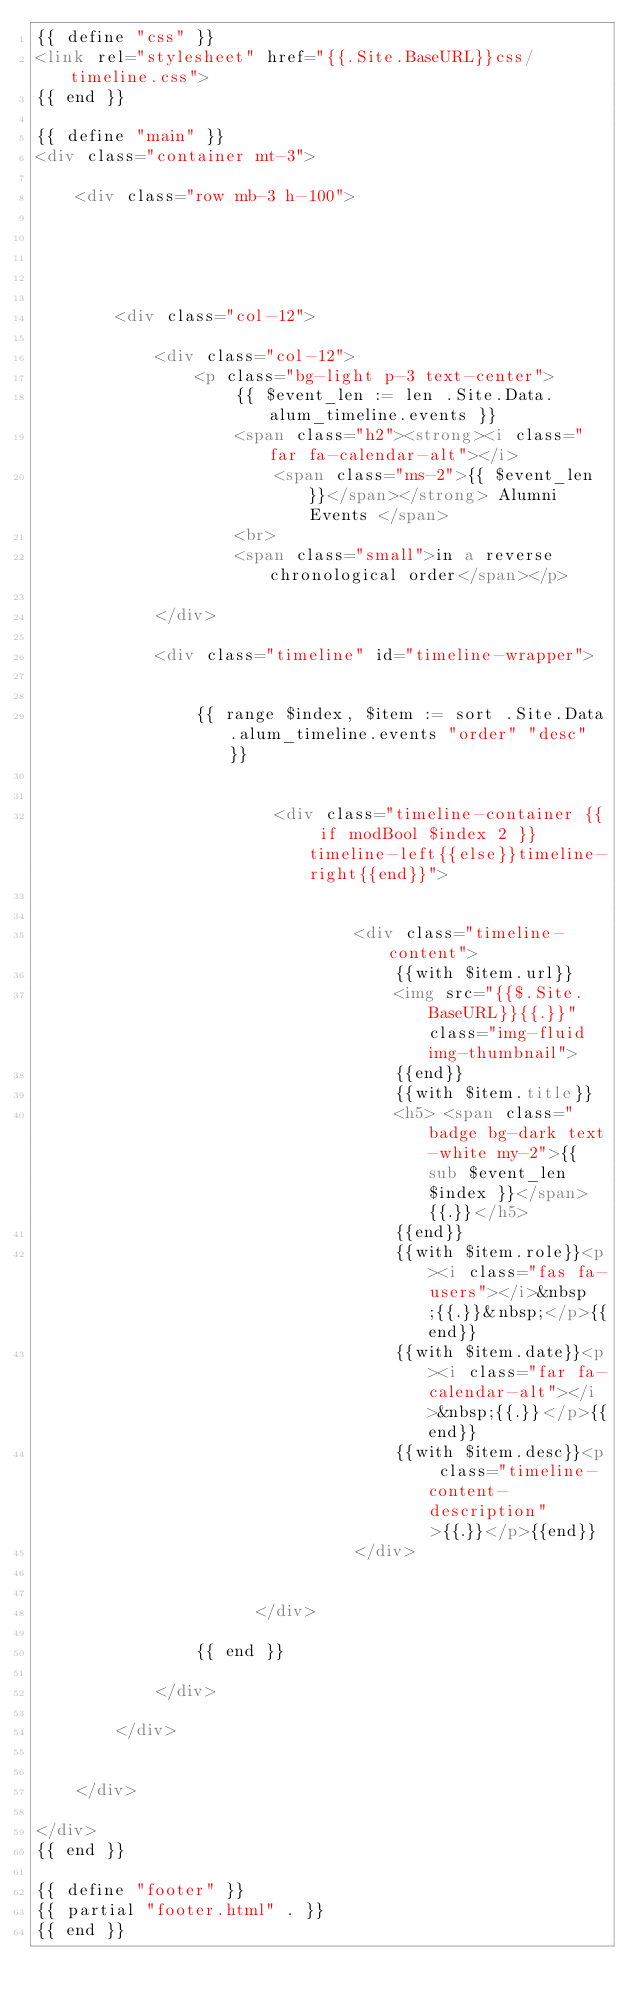<code> <loc_0><loc_0><loc_500><loc_500><_HTML_>{{ define "css" }}
<link rel="stylesheet" href="{{.Site.BaseURL}}css/timeline.css">
{{ end }}

{{ define "main" }}
<div class="container mt-3">

    <div class="row mb-3 h-100">





        <div class="col-12">

            <div class="col-12">
                <p class="bg-light p-3 text-center">
                    {{ $event_len := len .Site.Data.alum_timeline.events }}
                    <span class="h2"><strong><i class="far fa-calendar-alt"></i>
                        <span class="ms-2">{{ $event_len }}</span></strong> Alumni Events </span>
                    <br>
                    <span class="small">in a reverse chronological order</span></p>

            </div>

            <div class="timeline" id="timeline-wrapper">


                {{ range $index, $item := sort .Site.Data.alum_timeline.events "order" "desc" }}


                        <div class="timeline-container {{ if modBool $index 2 }}timeline-left{{else}}timeline-right{{end}}">


                                <div class="timeline-content">
                                    {{with $item.url}}
                                    <img src="{{$.Site.BaseURL}}{{.}}" class="img-fluid img-thumbnail">
                                    {{end}}
                                    {{with $item.title}}
                                    <h5> <span class="badge bg-dark text-white my-2">{{ sub $event_len $index }}</span> {{.}}</h5>
                                    {{end}}
                                    {{with $item.role}}<p><i class="fas fa-users"></i>&nbsp;{{.}}&nbsp;</p>{{end}}
                                    {{with $item.date}}<p><i class="far fa-calendar-alt"></i>&nbsp;{{.}}</p>{{end}}
                                    {{with $item.desc}}<p class="timeline-content-description">{{.}}</p>{{end}}
                                </div>


                      </div>

                {{ end }}

            </div>

        </div>


    </div>

</div>
{{ end }}

{{ define "footer" }}
{{ partial "footer.html" . }}
{{ end }}
</code> 